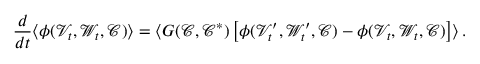Convert formula to latex. <formula><loc_0><loc_0><loc_500><loc_500>\frac { d } { d t } \langle \phi ( \mathcal { V } _ { t } , \mathcal { W } _ { t } , \mathcal { C } ) \rangle = \langle G ( \mathcal { C } , \mathcal { C } ^ { * } ) \left [ \phi ( \mathcal { V } _ { t } ^ { \prime } , \mathcal { W } _ { t } ^ { \prime } , \mathcal { C } ) - \phi ( \mathcal { V } _ { t } , \mathcal { W } _ { t } , \mathcal { C } ) \right ] \rangle \, .</formula> 